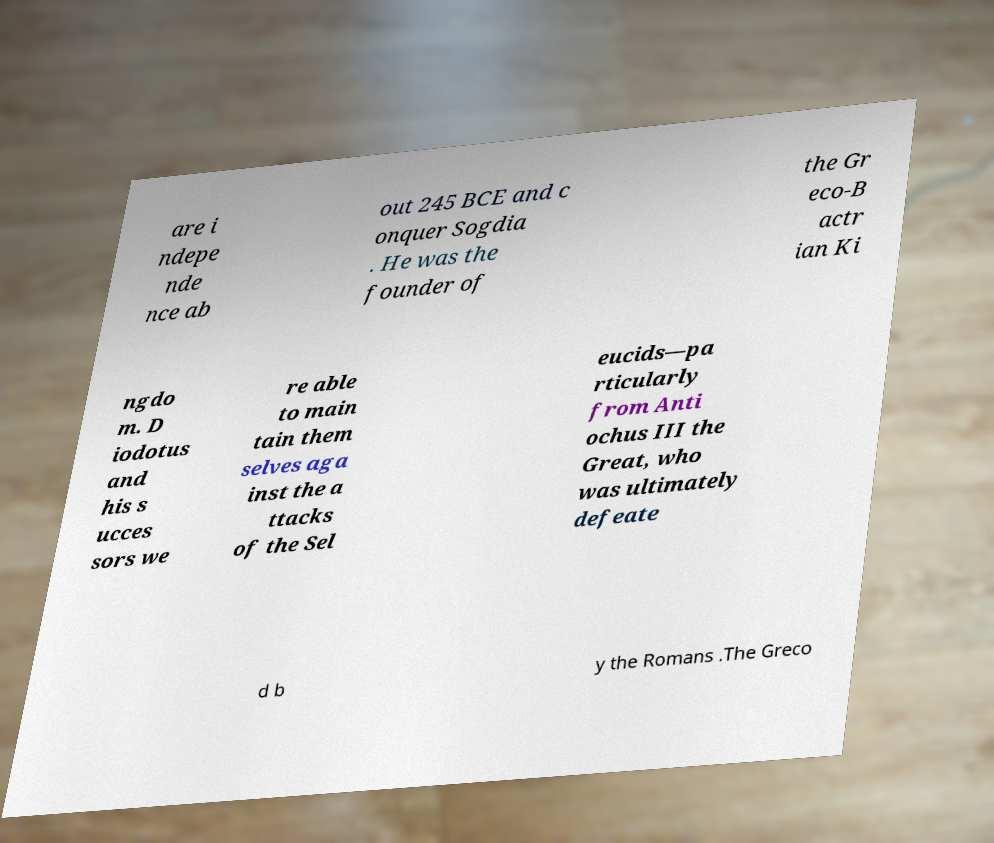Please identify and transcribe the text found in this image. are i ndepe nde nce ab out 245 BCE and c onquer Sogdia . He was the founder of the Gr eco-B actr ian Ki ngdo m. D iodotus and his s ucces sors we re able to main tain them selves aga inst the a ttacks of the Sel eucids—pa rticularly from Anti ochus III the Great, who was ultimately defeate d b y the Romans .The Greco 